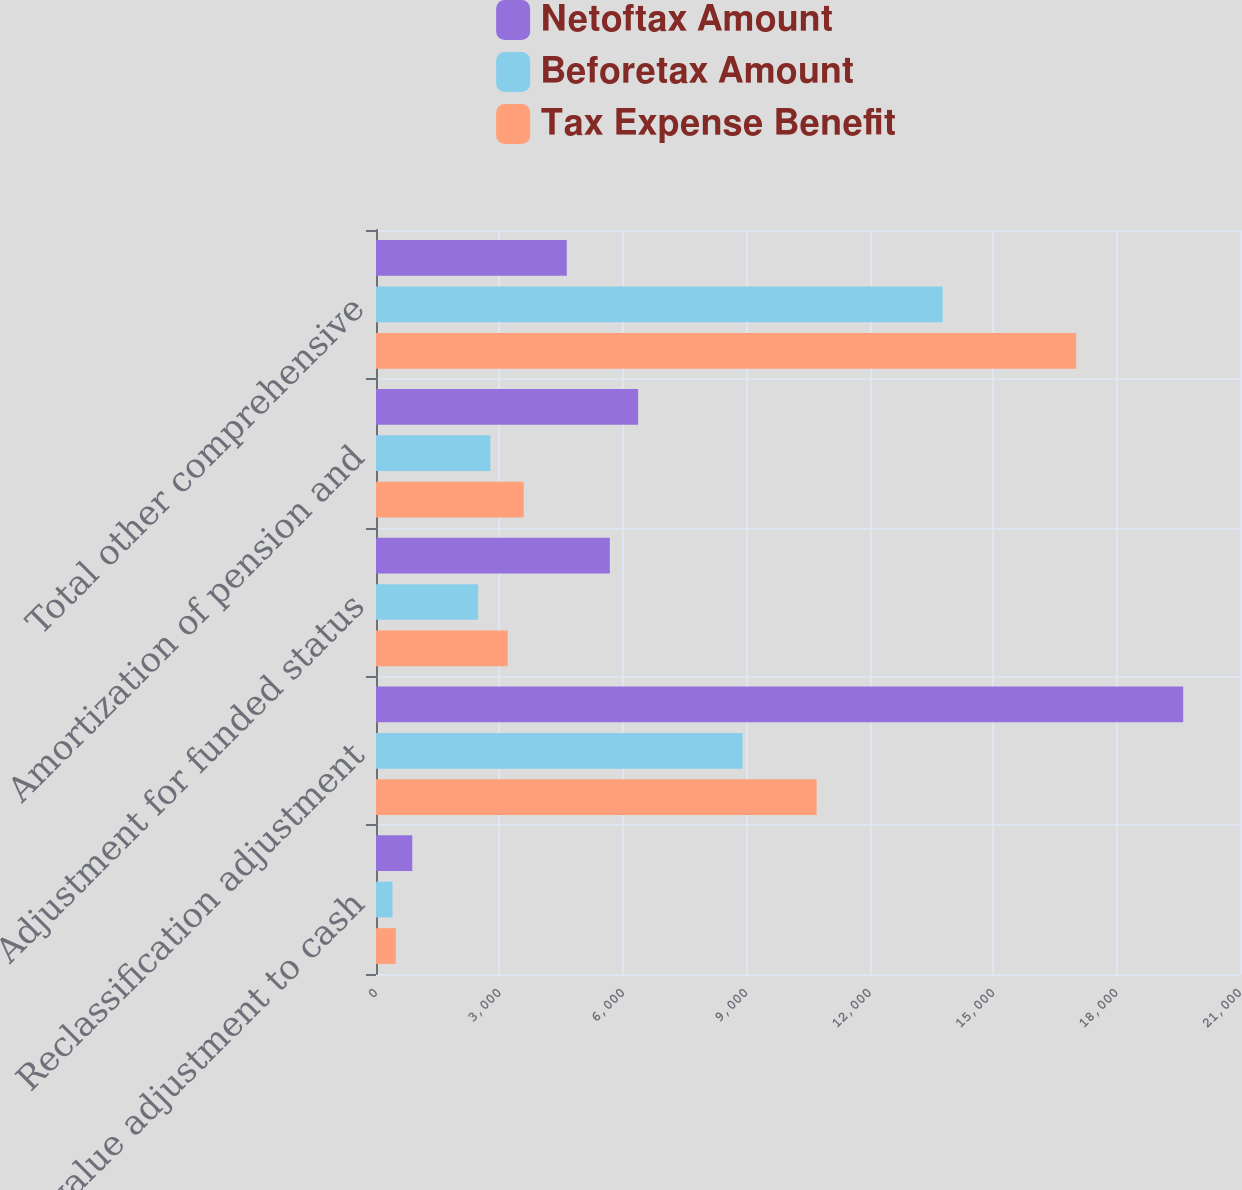Convert chart to OTSL. <chart><loc_0><loc_0><loc_500><loc_500><stacked_bar_chart><ecel><fcel>Fair value adjustment to cash<fcel>Reclassification adjustment<fcel>Adjustment for funded status<fcel>Amortization of pension and<fcel>Total other comprehensive<nl><fcel>Netoftax Amount<fcel>882<fcel>19619<fcel>5683<fcel>6371<fcel>4636.5<nl><fcel>Beforetax Amount<fcel>401<fcel>8910<fcel>2482<fcel>2781<fcel>13772<nl><fcel>Tax Expense Benefit<fcel>481<fcel>10709<fcel>3201<fcel>3590<fcel>17019<nl></chart> 